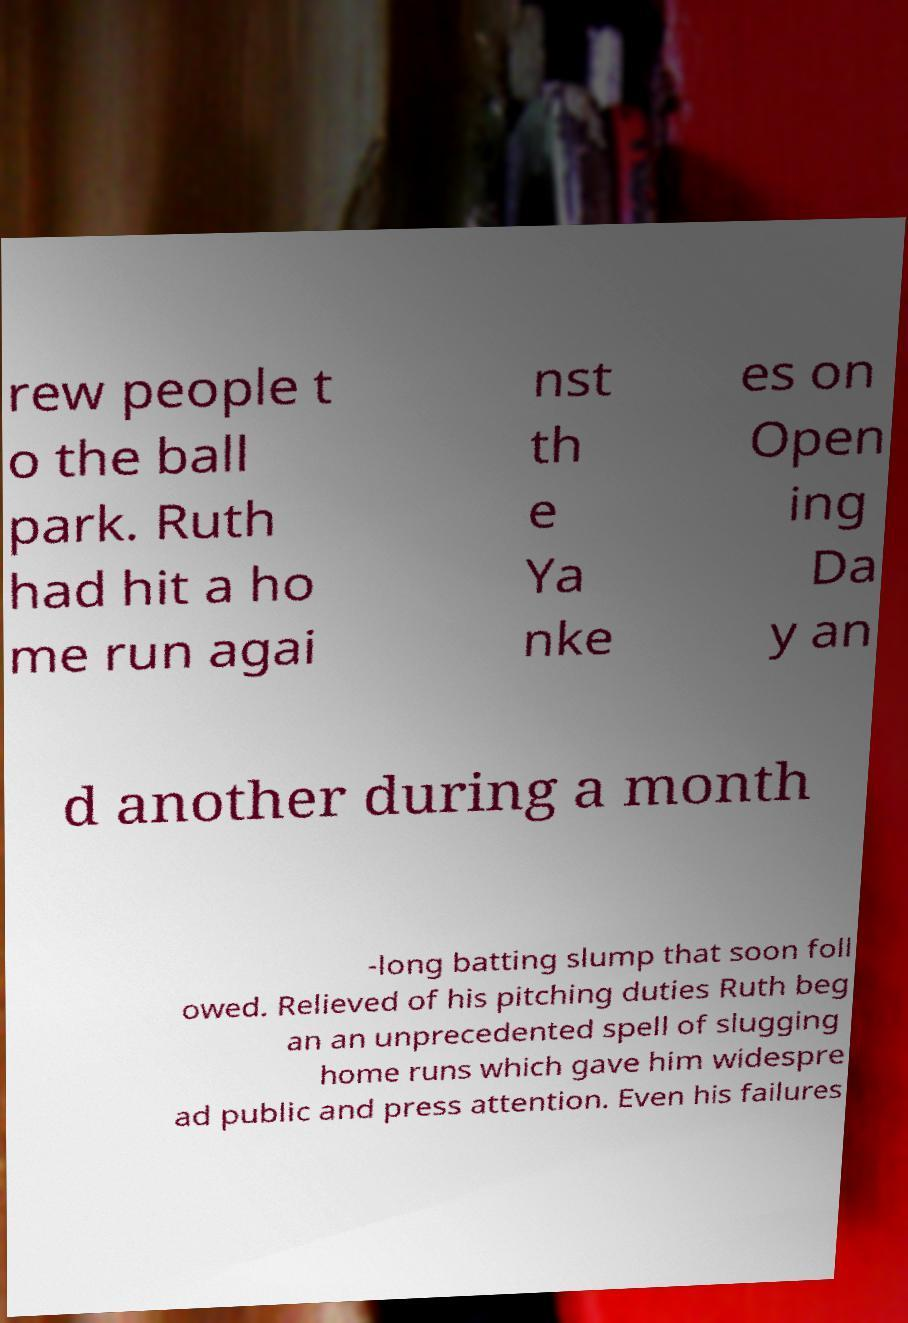Please identify and transcribe the text found in this image. rew people t o the ball park. Ruth had hit a ho me run agai nst th e Ya nke es on Open ing Da y an d another during a month -long batting slump that soon foll owed. Relieved of his pitching duties Ruth beg an an unprecedented spell of slugging home runs which gave him widespre ad public and press attention. Even his failures 